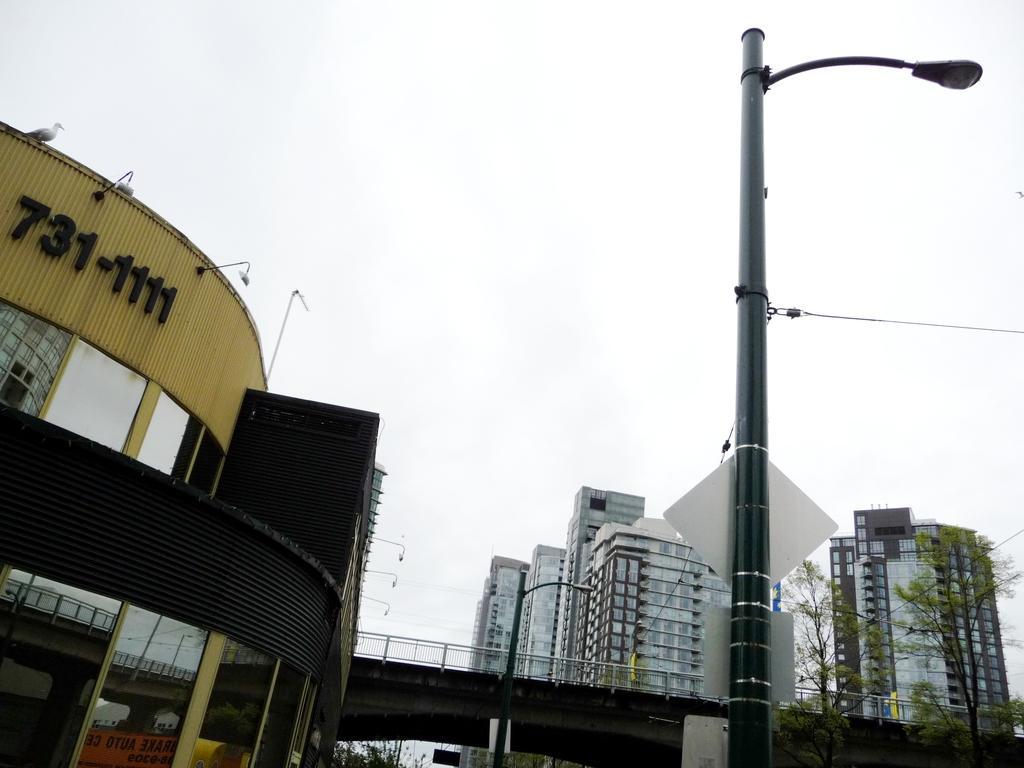What type of structures can be seen in the image? There are street lights and a bridge at the center of the image. What is located behind the bridge in the image? There are buildings, trees, and the sky visible in the background of the image. Can you tell me how many monkeys are sitting on the bridge in the image? There are no monkeys present in the image; it features a bridge, street lights, buildings, trees, and the sky. What type of jelly can be seen in the image? There is no jelly present in the image. 